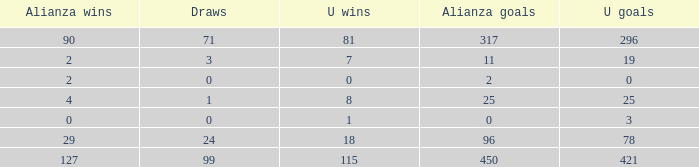When alianza goals are "0" and u goals are more than 3, what is the count of u wins? 0.0. 